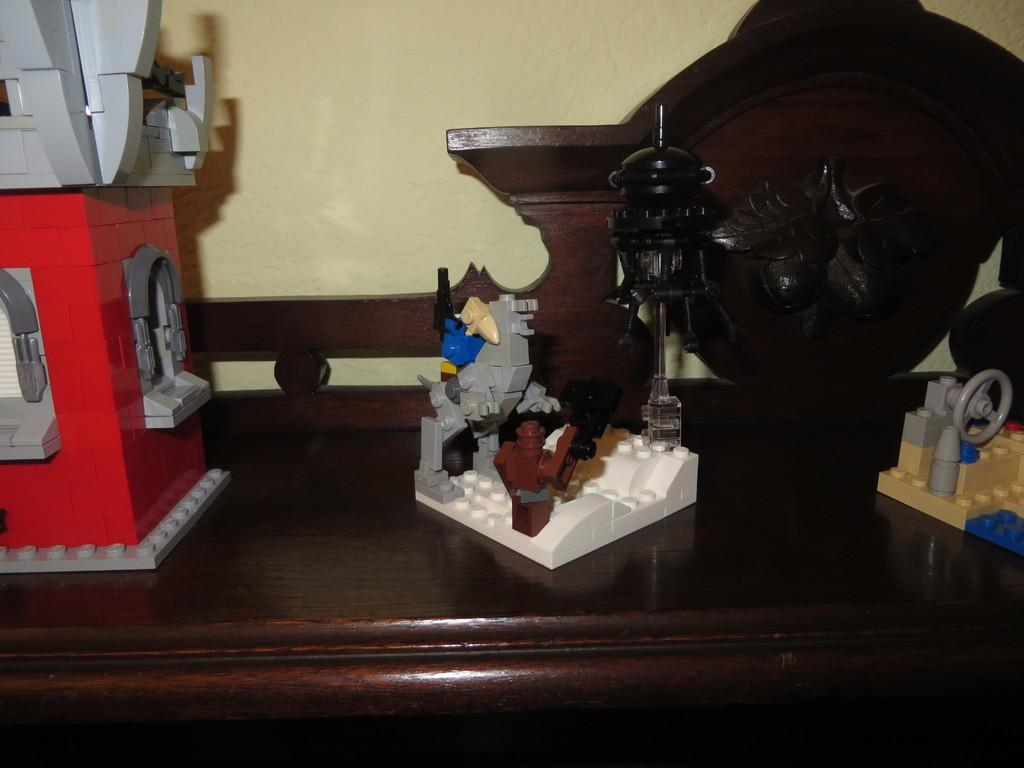What is the main object in the image? There is a table in the image. What is placed on the table? There are Lego toys on the table. What can be seen in the background of the image? There is a wall in the background of the image. What type of craft is visible in the image? There is a wooden craft in the image. What rule is being enforced on the island in the image? There is no island present in the image, and therefore no rule can be enforced. What is the name of the person who created the wooden craft in the image? The image does not provide information about the creator of the wooden craft, so we cannot determine their name. 